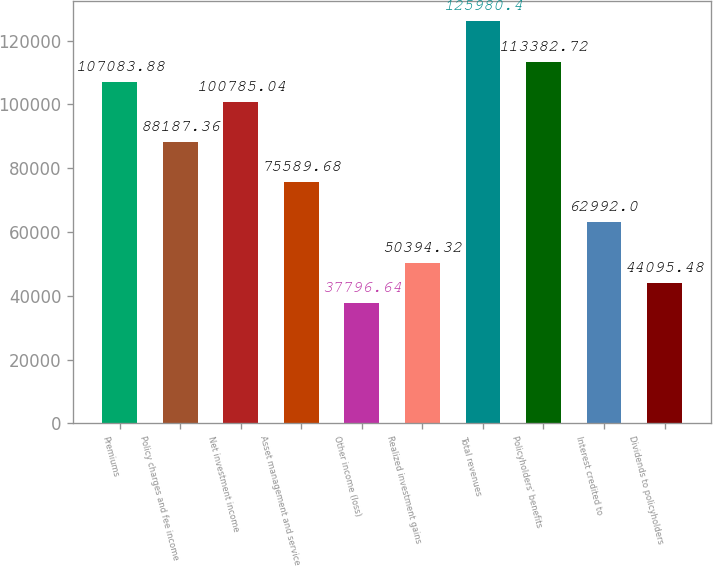Convert chart to OTSL. <chart><loc_0><loc_0><loc_500><loc_500><bar_chart><fcel>Premiums<fcel>Policy charges and fee income<fcel>Net investment income<fcel>Asset management and service<fcel>Other income (loss)<fcel>Realized investment gains<fcel>Total revenues<fcel>Policyholders' benefits<fcel>Interest credited to<fcel>Dividends to policyholders<nl><fcel>107084<fcel>88187.4<fcel>100785<fcel>75589.7<fcel>37796.6<fcel>50394.3<fcel>125980<fcel>113383<fcel>62992<fcel>44095.5<nl></chart> 